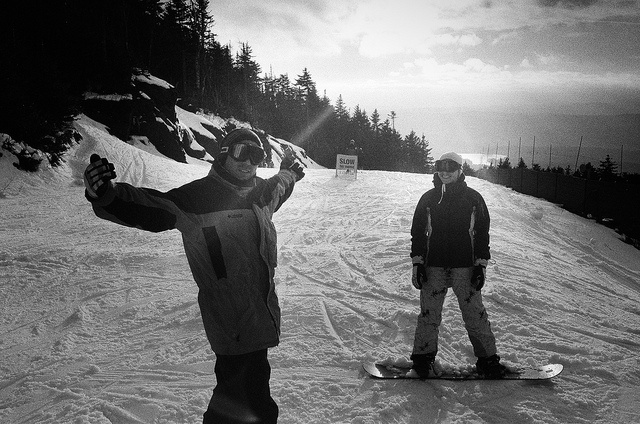Describe the objects in this image and their specific colors. I can see people in black, gray, darkgray, and lightgray tones, people in black, gray, darkgray, and lightgray tones, and snowboard in black, gray, darkgray, and lightgray tones in this image. 